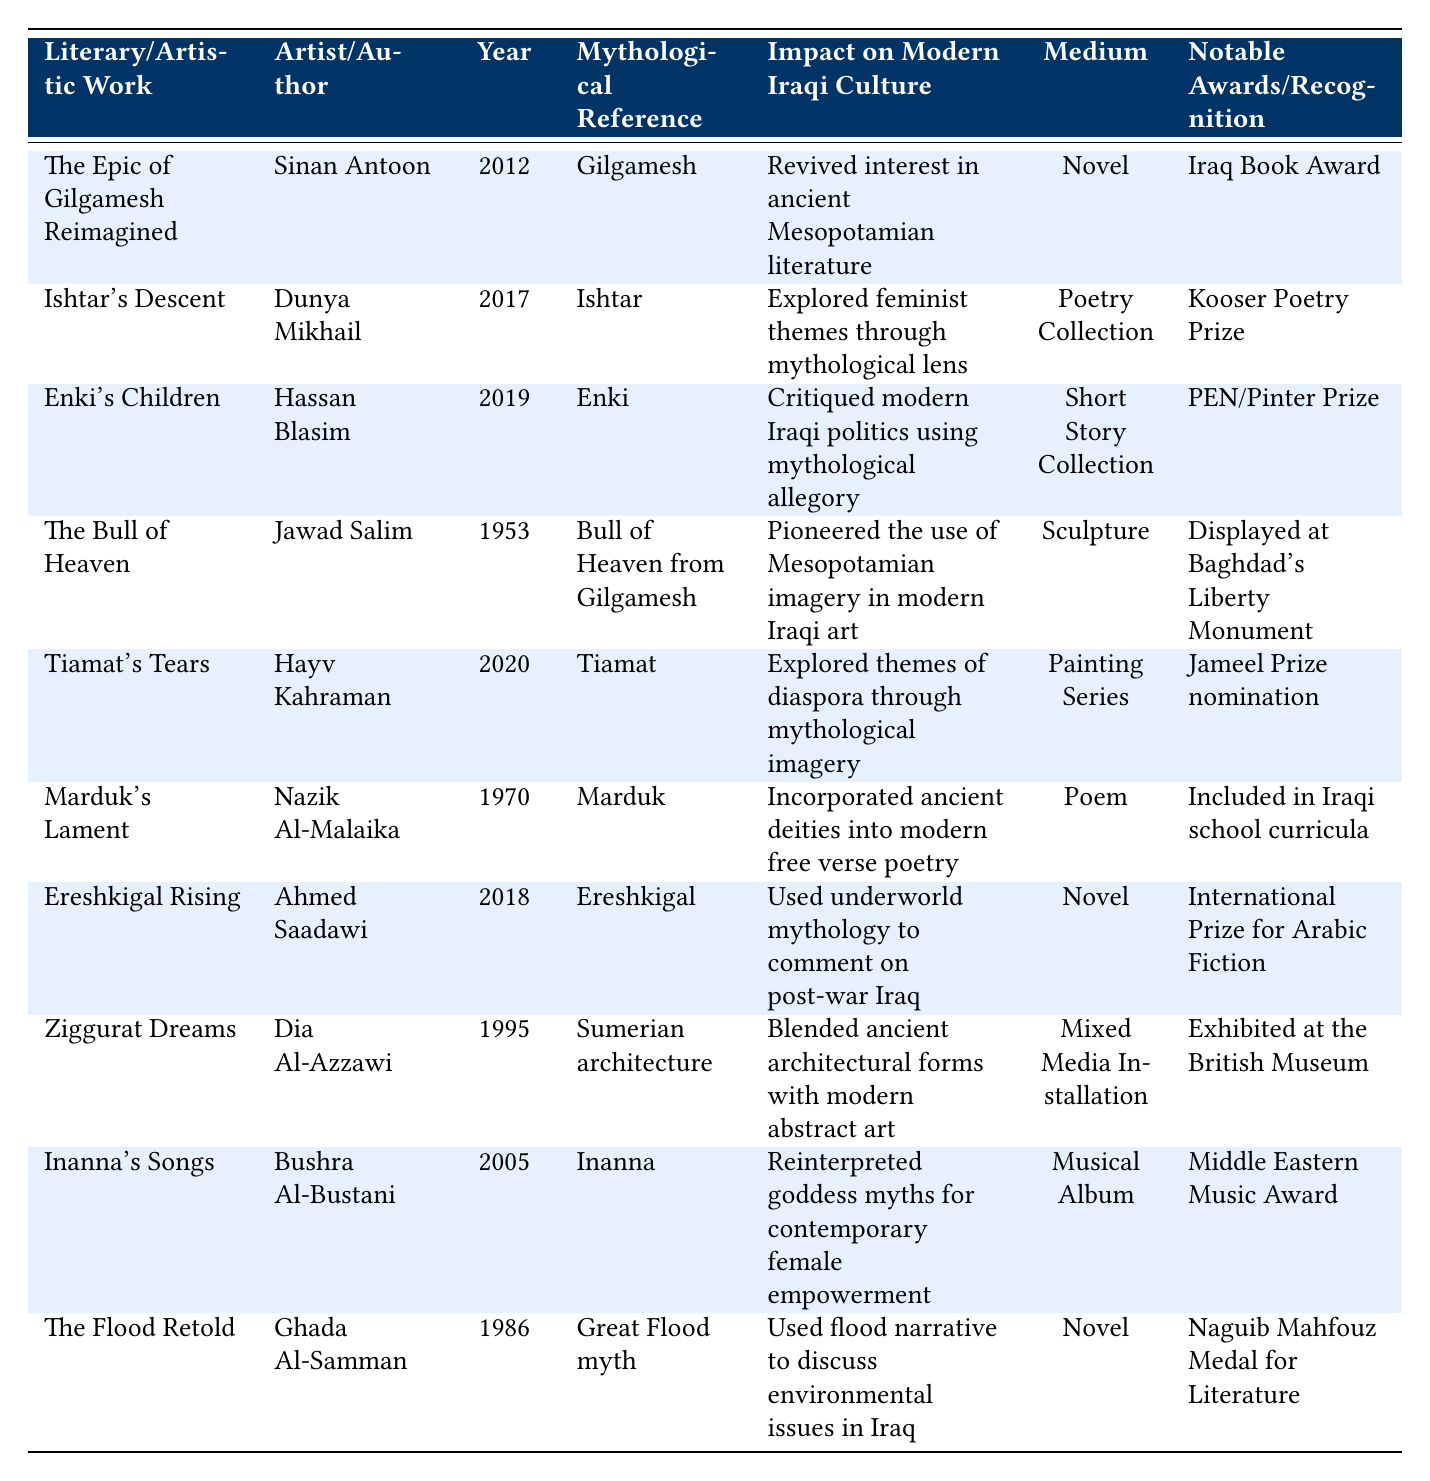What is the medium of "The Epic of Gilgamesh Reimagined"? In the table, the row for "The Epic of Gilgamesh Reimagined" indicates the medium is classified as a "Novel."
Answer: Novel Which artist created "Tiamat's Tears"? The table shows that "Tiamat's Tears" was created by Hayv Kahraman.
Answer: Hayv Kahraman What year was "Enki's Children" published? The table lists the publication year for "Enki's Children" as 2019.
Answer: 2019 How many artistic works reference the goddess Ishtar? The table shows that only one work, "Ishtar's Descent," references the goddess Ishtar.
Answer: 1 What impact did "Marduk's Lament" have on modern Iraqi culture? The table states that "Marduk's Lament" incorporated ancient deities into modern free verse poetry, indicating its cultural significance.
Answer: Incorporated ancient deities into modern free verse poetry Which two works received notable awards for their excellence? According to the table, "Ishtar's Descent" received the Kooser Poetry Prize and "Ereshkigal Rising" received the International Prize for Arabic Fiction.
Answer: 2 Is "The Flood Retold" a novel or a poem? The table classifies "The Flood Retold" as a "Novel."
Answer: Novel Who among the listed artists has displayed a work at the British Museum? The table specifically notes that Dia Al-Azzawi's work "Ziggurat Dreams" was exhibited at the British Museum.
Answer: Dia Al-Azzawi Which literary work critiques modern Iraqi politics? The table indicates that "Enki's Children" critiques modern Iraqi politics through mythological allegory.
Answer: Enki's Children Sum the years in which "Ereshkigal Rising" and "Ishtar's Descent" were published. "Ereshkigal Rising" was published in 2018 and "Ishtar's Descent" in 2017. Adding these gives 2018 + 2017 = 4035.
Answer: 4035 Which work considers environmental issues in Iraq, and what is its medium? The table shows that "The Flood Retold" discusses environmental issues and is categorized as a "Novel."
Answer: The Flood Retold, Novel 